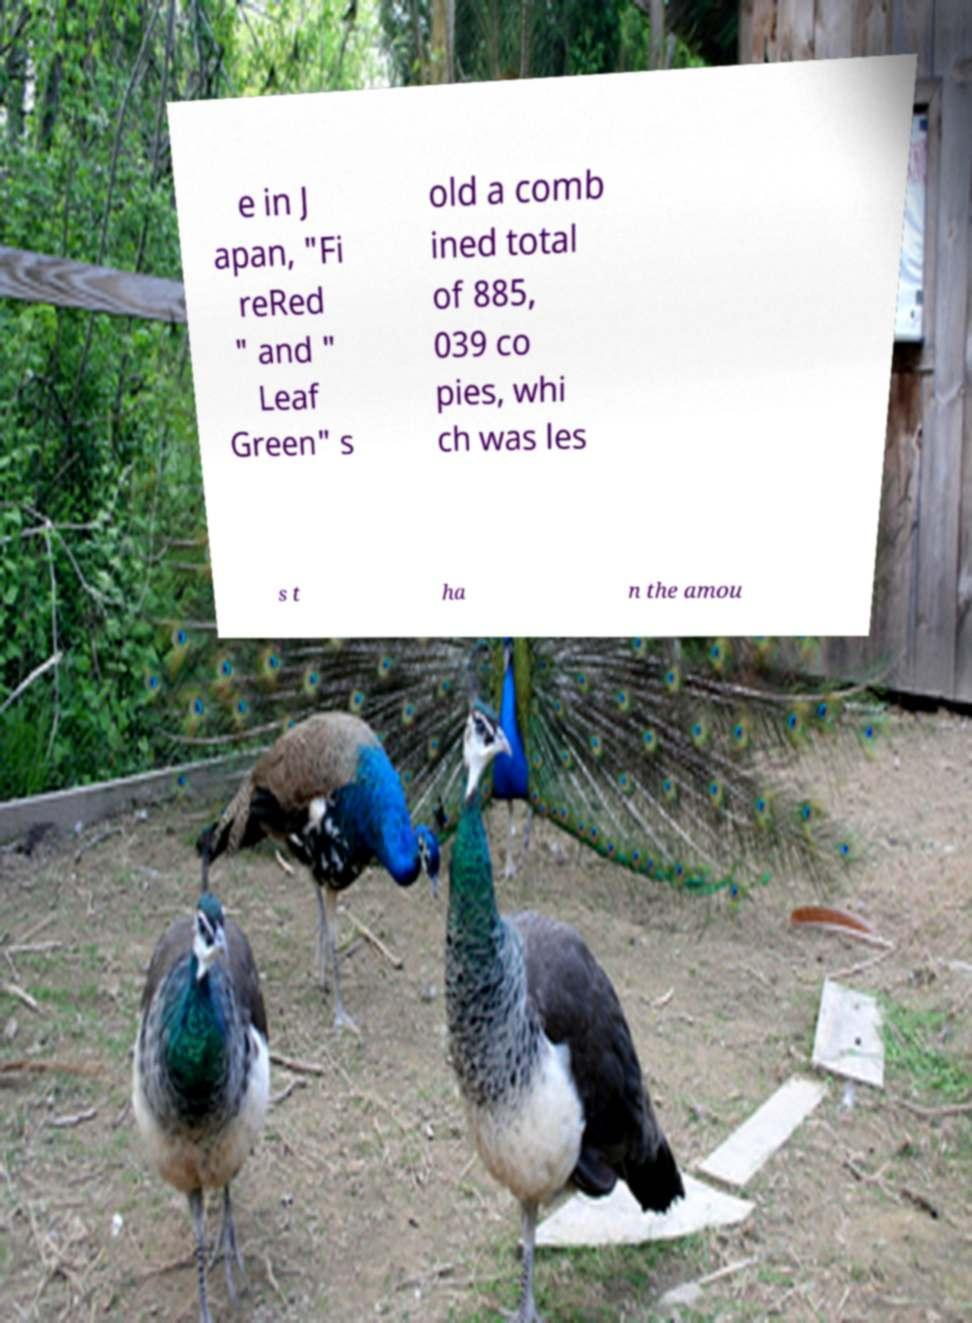Please identify and transcribe the text found in this image. e in J apan, "Fi reRed " and " Leaf Green" s old a comb ined total of 885, 039 co pies, whi ch was les s t ha n the amou 